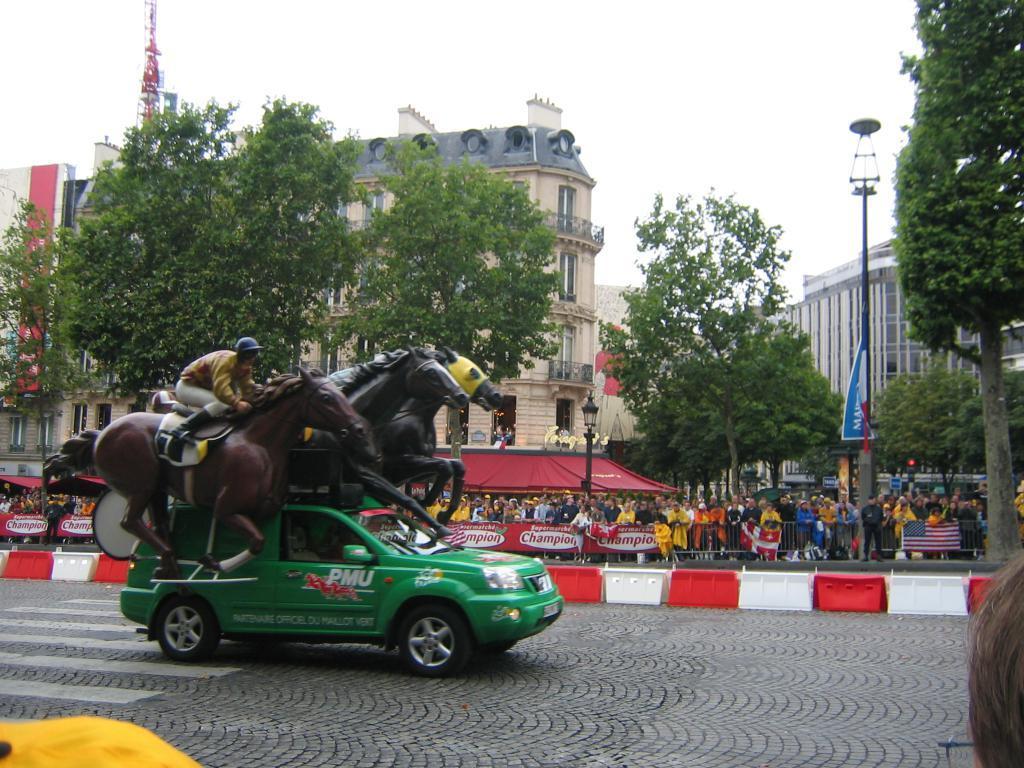Could you give a brief overview of what you see in this image? In this image on the road a car is moving. On it there are statues of horses , drum and a person is there. In the background beside the road there are many people. Beside the road there is barricade, on it there are banners, flag. In the background there are buildings, trees, poles,street lights, towers are there. 